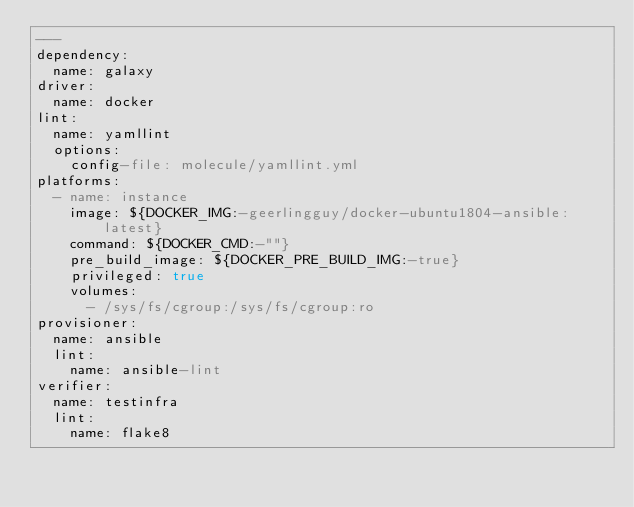<code> <loc_0><loc_0><loc_500><loc_500><_YAML_>---
dependency:
  name: galaxy
driver:
  name: docker
lint:
  name: yamllint
  options:
    config-file: molecule/yamllint.yml
platforms:
  - name: instance
    image: ${DOCKER_IMG:-geerlingguy/docker-ubuntu1804-ansible:latest}
    command: ${DOCKER_CMD:-""}
    pre_build_image: ${DOCKER_PRE_BUILD_IMG:-true}
    privileged: true
    volumes:
      - /sys/fs/cgroup:/sys/fs/cgroup:ro
provisioner:
  name: ansible
  lint:
    name: ansible-lint
verifier:
  name: testinfra
  lint:
    name: flake8
</code> 